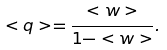<formula> <loc_0><loc_0><loc_500><loc_500>< q > = \frac { < w > } { 1 - < w > } .</formula> 